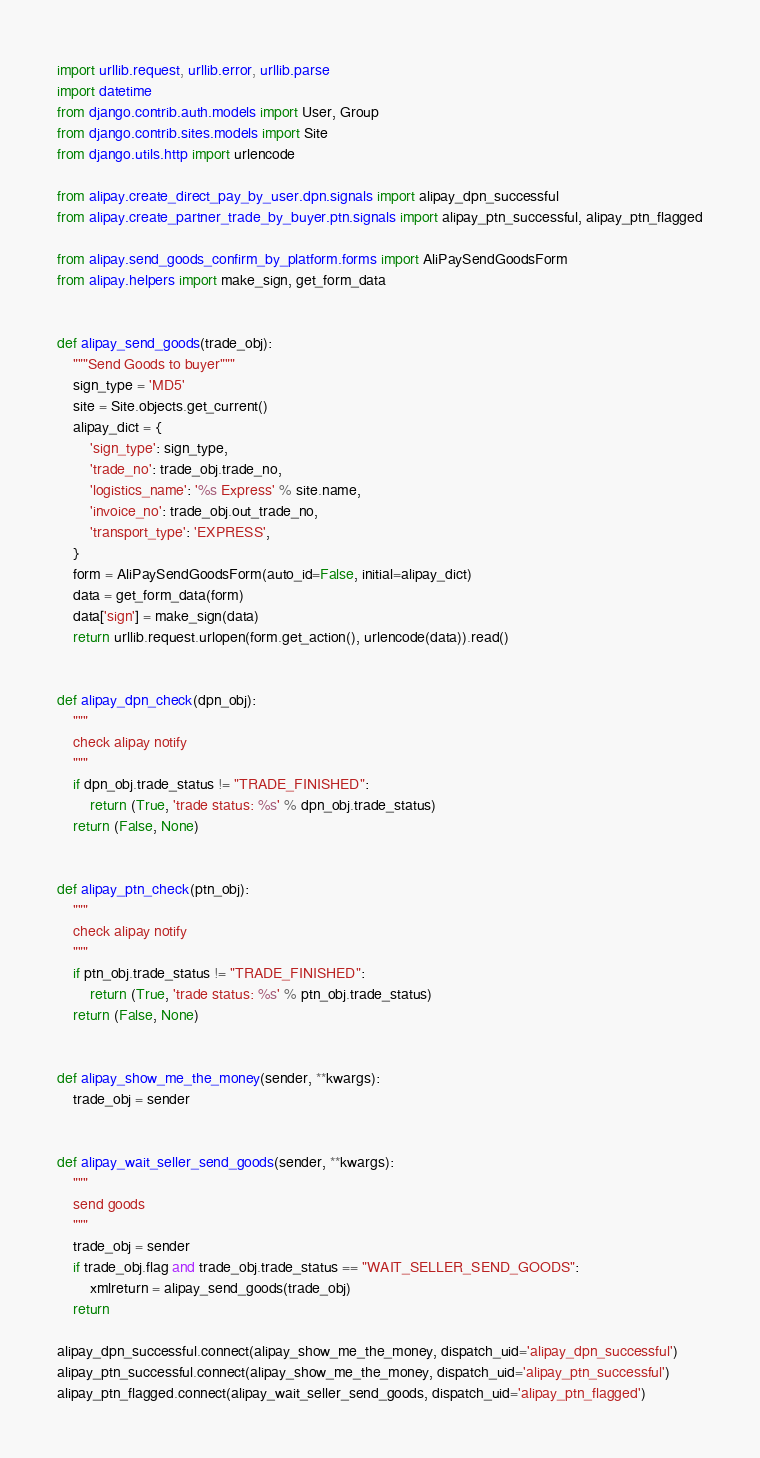<code> <loc_0><loc_0><loc_500><loc_500><_Python_>
import urllib.request, urllib.error, urllib.parse
import datetime
from django.contrib.auth.models import User, Group
from django.contrib.sites.models import Site
from django.utils.http import urlencode

from alipay.create_direct_pay_by_user.dpn.signals import alipay_dpn_successful
from alipay.create_partner_trade_by_buyer.ptn.signals import alipay_ptn_successful, alipay_ptn_flagged

from alipay.send_goods_confirm_by_platform.forms import AliPaySendGoodsForm
from alipay.helpers import make_sign, get_form_data


def alipay_send_goods(trade_obj):
    """Send Goods to buyer"""
    sign_type = 'MD5'
    site = Site.objects.get_current()
    alipay_dict = {
        'sign_type': sign_type,
        'trade_no': trade_obj.trade_no,
        'logistics_name': '%s Express' % site.name,
        'invoice_no': trade_obj.out_trade_no,
        'transport_type': 'EXPRESS',
    }
    form = AliPaySendGoodsForm(auto_id=False, initial=alipay_dict)
    data = get_form_data(form)
    data['sign'] = make_sign(data)
    return urllib.request.urlopen(form.get_action(), urlencode(data)).read()


def alipay_dpn_check(dpn_obj):
    """
    check alipay notify
    """
    if dpn_obj.trade_status != "TRADE_FINISHED":
        return (True, 'trade status: %s' % dpn_obj.trade_status)
    return (False, None)


def alipay_ptn_check(ptn_obj):
    """
    check alipay notify
    """
    if ptn_obj.trade_status != "TRADE_FINISHED":
        return (True, 'trade status: %s' % ptn_obj.trade_status)
    return (False, None)


def alipay_show_me_the_money(sender, **kwargs):
    trade_obj = sender


def alipay_wait_seller_send_goods(sender, **kwargs):
    """
    send goods
    """
    trade_obj = sender
    if trade_obj.flag and trade_obj.trade_status == "WAIT_SELLER_SEND_GOODS":
        xmlreturn = alipay_send_goods(trade_obj)
    return

alipay_dpn_successful.connect(alipay_show_me_the_money, dispatch_uid='alipay_dpn_successful')
alipay_ptn_successful.connect(alipay_show_me_the_money, dispatch_uid='alipay_ptn_successful')
alipay_ptn_flagged.connect(alipay_wait_seller_send_goods, dispatch_uid='alipay_ptn_flagged')
</code> 